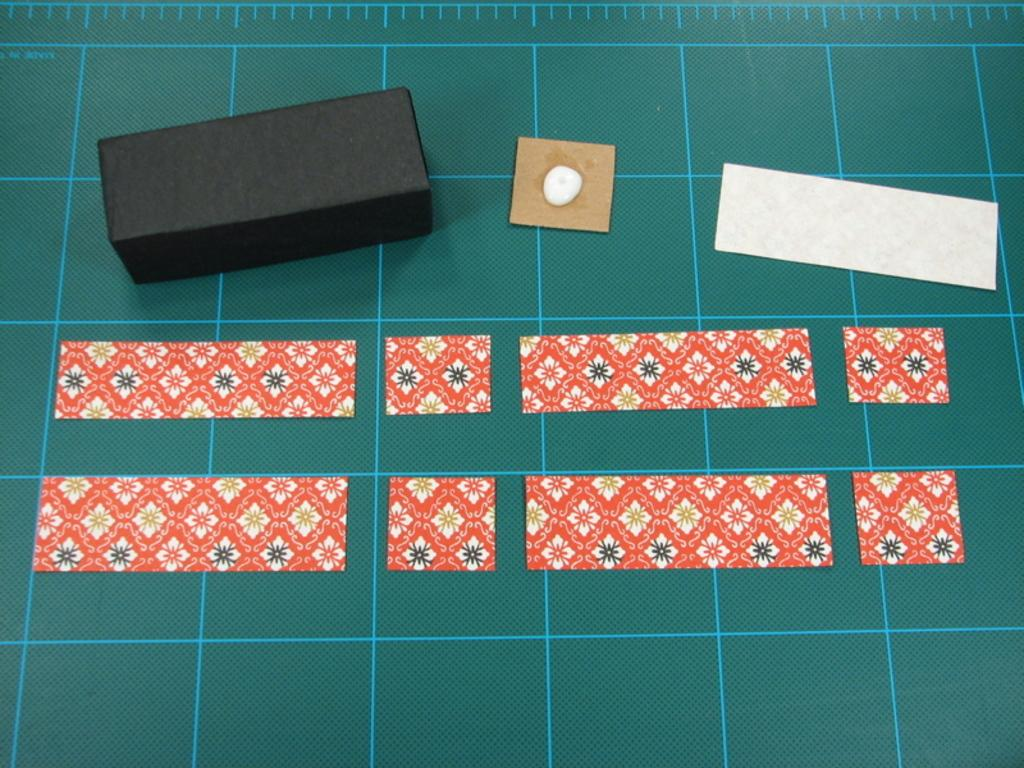What is the color of the box in the image? The box in the image is black. What material is present in the image besides the box? There is cardboard and decorative papers in the image. What is the purpose of the mat in the image? The mat in the image has measuring lines on it, which suggests it might be used for measuring or cutting materials. How many icicles are hanging from the box in the image? There are no icicles present in the image; it is an indoor scene with no ice or icicles visible. 